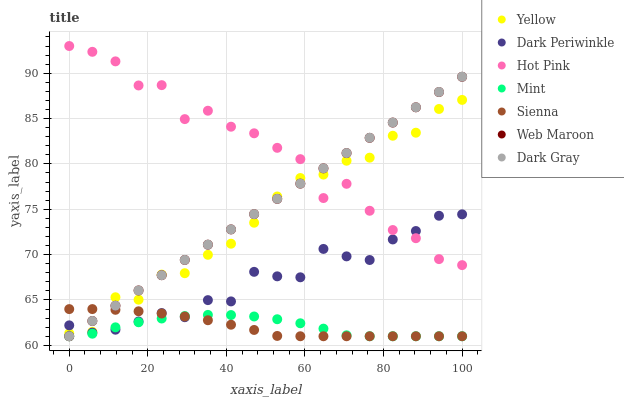Does Mint have the minimum area under the curve?
Answer yes or no. Yes. Does Hot Pink have the maximum area under the curve?
Answer yes or no. Yes. Does Web Maroon have the minimum area under the curve?
Answer yes or no. No. Does Web Maroon have the maximum area under the curve?
Answer yes or no. No. Is Dark Gray the smoothest?
Answer yes or no. Yes. Is Hot Pink the roughest?
Answer yes or no. Yes. Is Web Maroon the smoothest?
Answer yes or no. No. Is Web Maroon the roughest?
Answer yes or no. No. Does Dark Gray have the lowest value?
Answer yes or no. Yes. Does Hot Pink have the lowest value?
Answer yes or no. No. Does Hot Pink have the highest value?
Answer yes or no. Yes. Does Web Maroon have the highest value?
Answer yes or no. No. Is Sienna less than Hot Pink?
Answer yes or no. Yes. Is Hot Pink greater than Sienna?
Answer yes or no. Yes. Does Yellow intersect Dark Periwinkle?
Answer yes or no. Yes. Is Yellow less than Dark Periwinkle?
Answer yes or no. No. Is Yellow greater than Dark Periwinkle?
Answer yes or no. No. Does Sienna intersect Hot Pink?
Answer yes or no. No. 